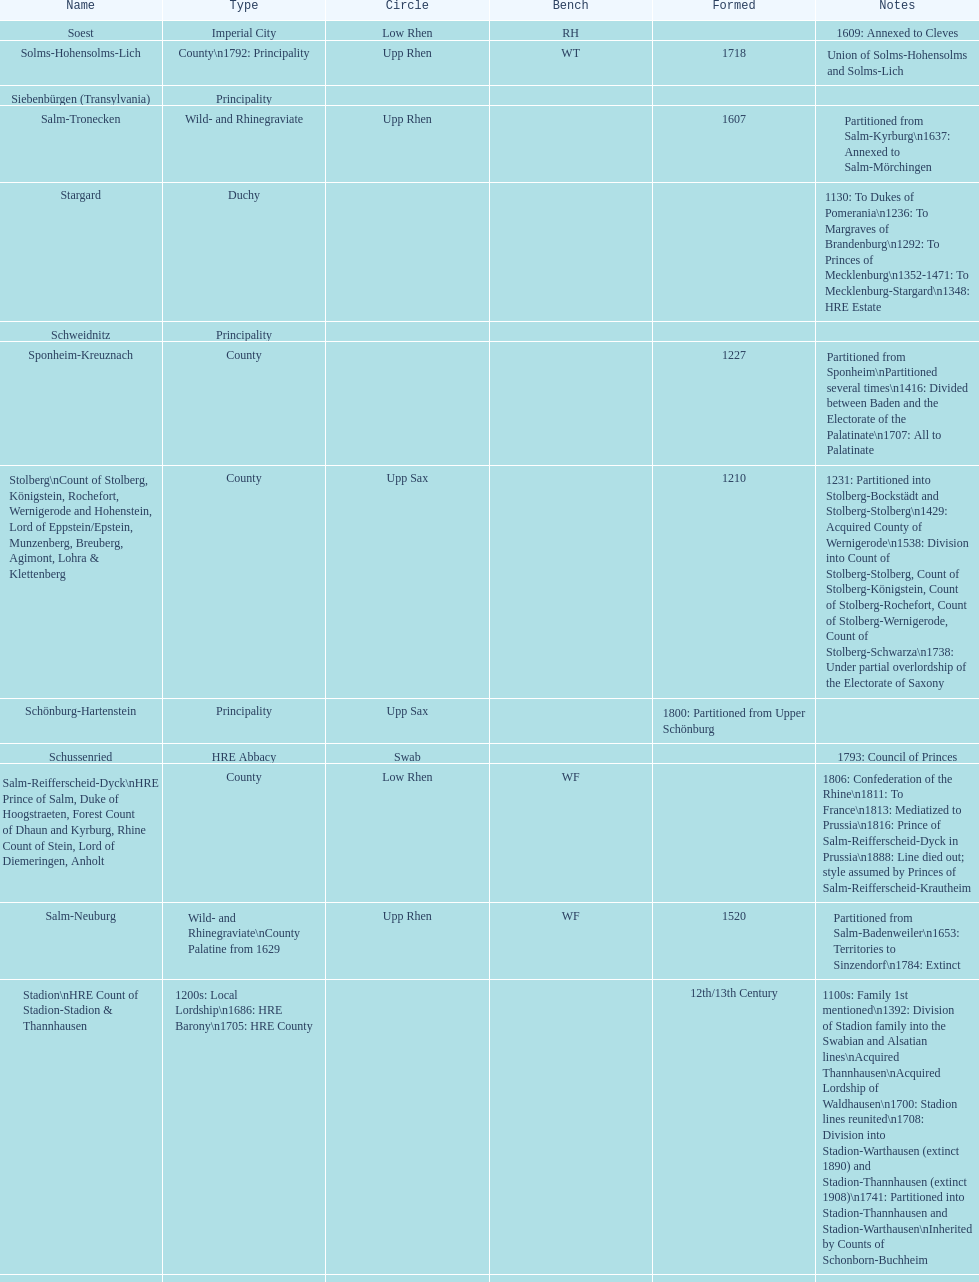Which bench is represented the most? PR. 